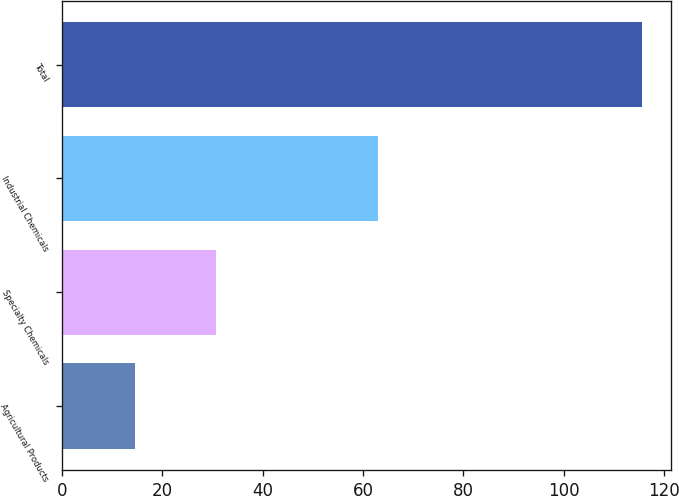Convert chart to OTSL. <chart><loc_0><loc_0><loc_500><loc_500><bar_chart><fcel>Agricultural Products<fcel>Specialty Chemicals<fcel>Industrial Chemicals<fcel>Total<nl><fcel>14.5<fcel>30.8<fcel>63<fcel>115.6<nl></chart> 